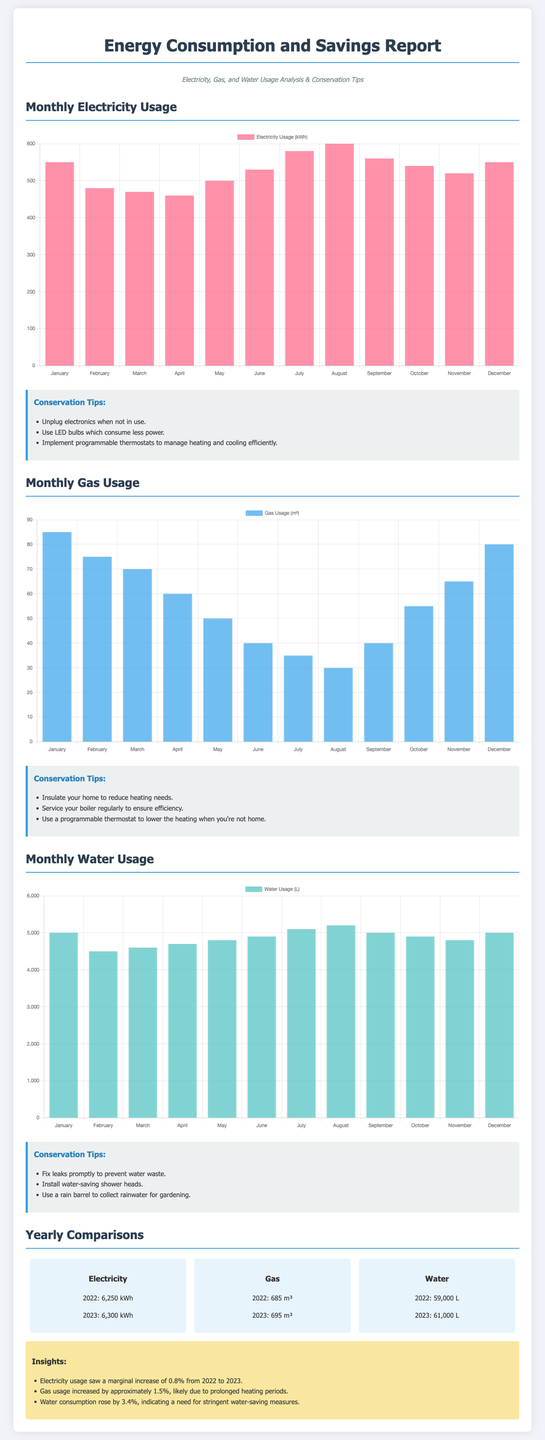what is the total electricity usage in 2023? The total electricity usage in 2023 is the sum of the monthly usages, which is 6300 kWh.
Answer: 6300 kWh how much gas was used in January 2023? The gas usage for January 2023 is displayed in the gas chart, specifically as 85 m³.
Answer: 85 m³ what conservation tip is provided for electricity? The document lists various conservation tips for electricity, one of which is to unplug electronics when not in use.
Answer: Unplug electronics when not in use what percentage increase did water consumption see from 2022 to 2023? The insights section mentions a 3.4% increase in water consumption from 2022 to 2023.
Answer: 3.4% how does 2023 electricity usage compare to 2022? The comparison section states that electricity usage increased by 0.8% from 2022 to 2023.
Answer: Increased by 0.8% which month had the highest water usage in 2023? By examining the water usage data, the month with the highest usage is July, with 5100 liters.
Answer: July what is the total water usage in 2022? The yearly water usage for 2022 is stated as 59,000 liters.
Answer: 59,000 L which gas conservation tip is provided? The tips section includes a suggestion to service your boiler regularly to ensure efficiency as a gas conservation tip.
Answer: Service your boiler regularly what is the color of the chart that represents gas usage? The color for the gas usage chart is specified as rgba(54, 162, 235, 0.7).
Answer: rgba(54, 162, 235, 0.7) 